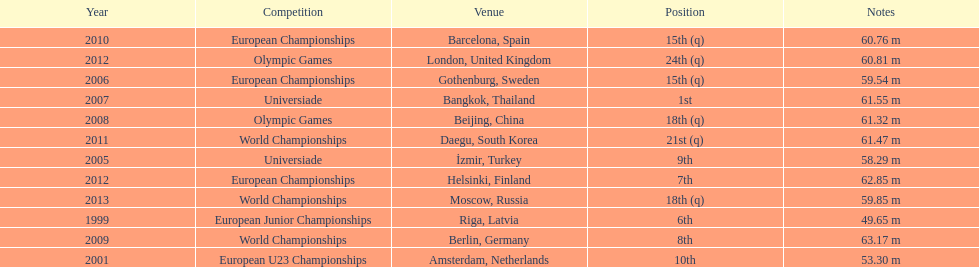Which year held the most competitions? 2012. 